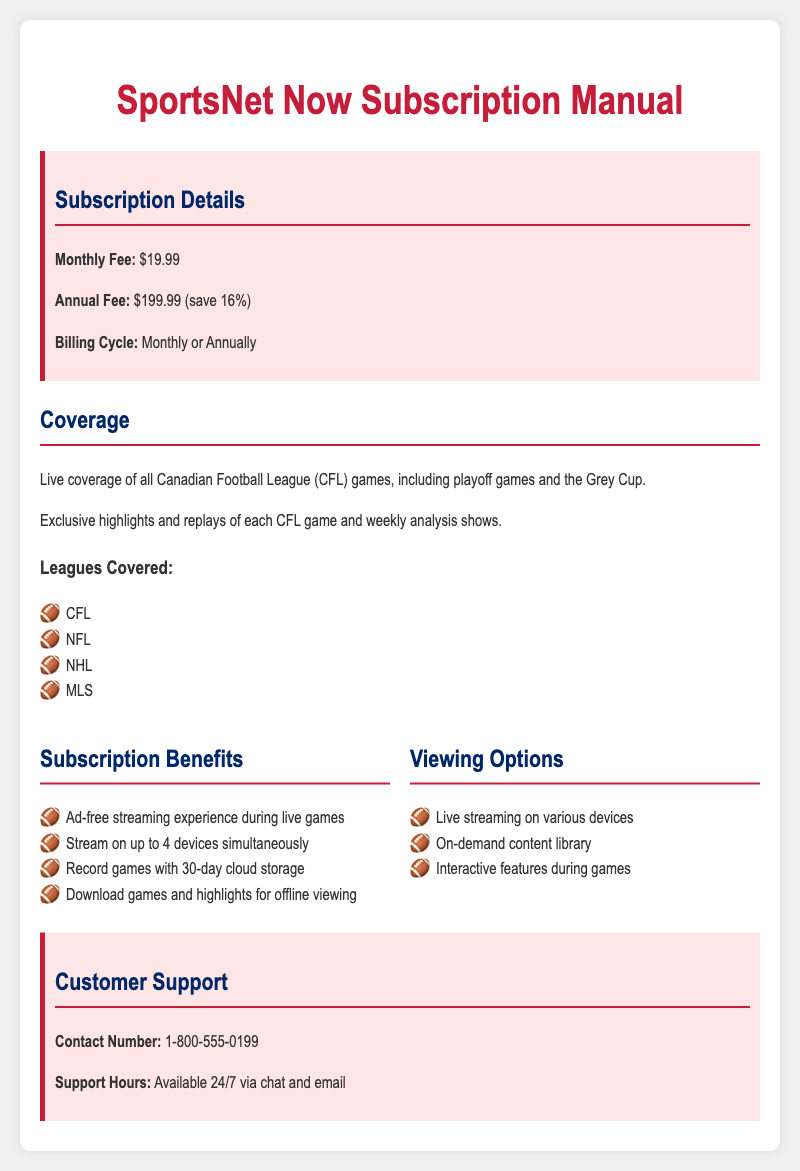What is the monthly fee? The monthly fee is listed clearly in the subscription details section of the document.
Answer: $19.99 What is the annual fee discount? The annual fee is provided alongside its saving details within the subscription details.
Answer: 16% Which leagues are covered? The document lists the leagues covered in a specific section, identifying them clearly.
Answer: CFL, NFL, NHL, MLS How many devices can you stream on simultaneously? It is mentioned in the subscription benefits section about the number of devices allowed for streaming.
Answer: 4 devices What support hours are available for customer help? The customer support section specifies the availability of support hours.
Answer: 24/7 What type of content can be recorded and stored? The subscription benefits mention what type of content can be recorded along with its storage duration.
Answer: Games Is the streaming experience ad-free? This information is indicated under subscription benefits, discussing the quality of the streaming experience.
Answer: Yes What feature is available for offline viewing? The subscription benefits explain features related to offline access to content.
Answer: Download games and highlights 